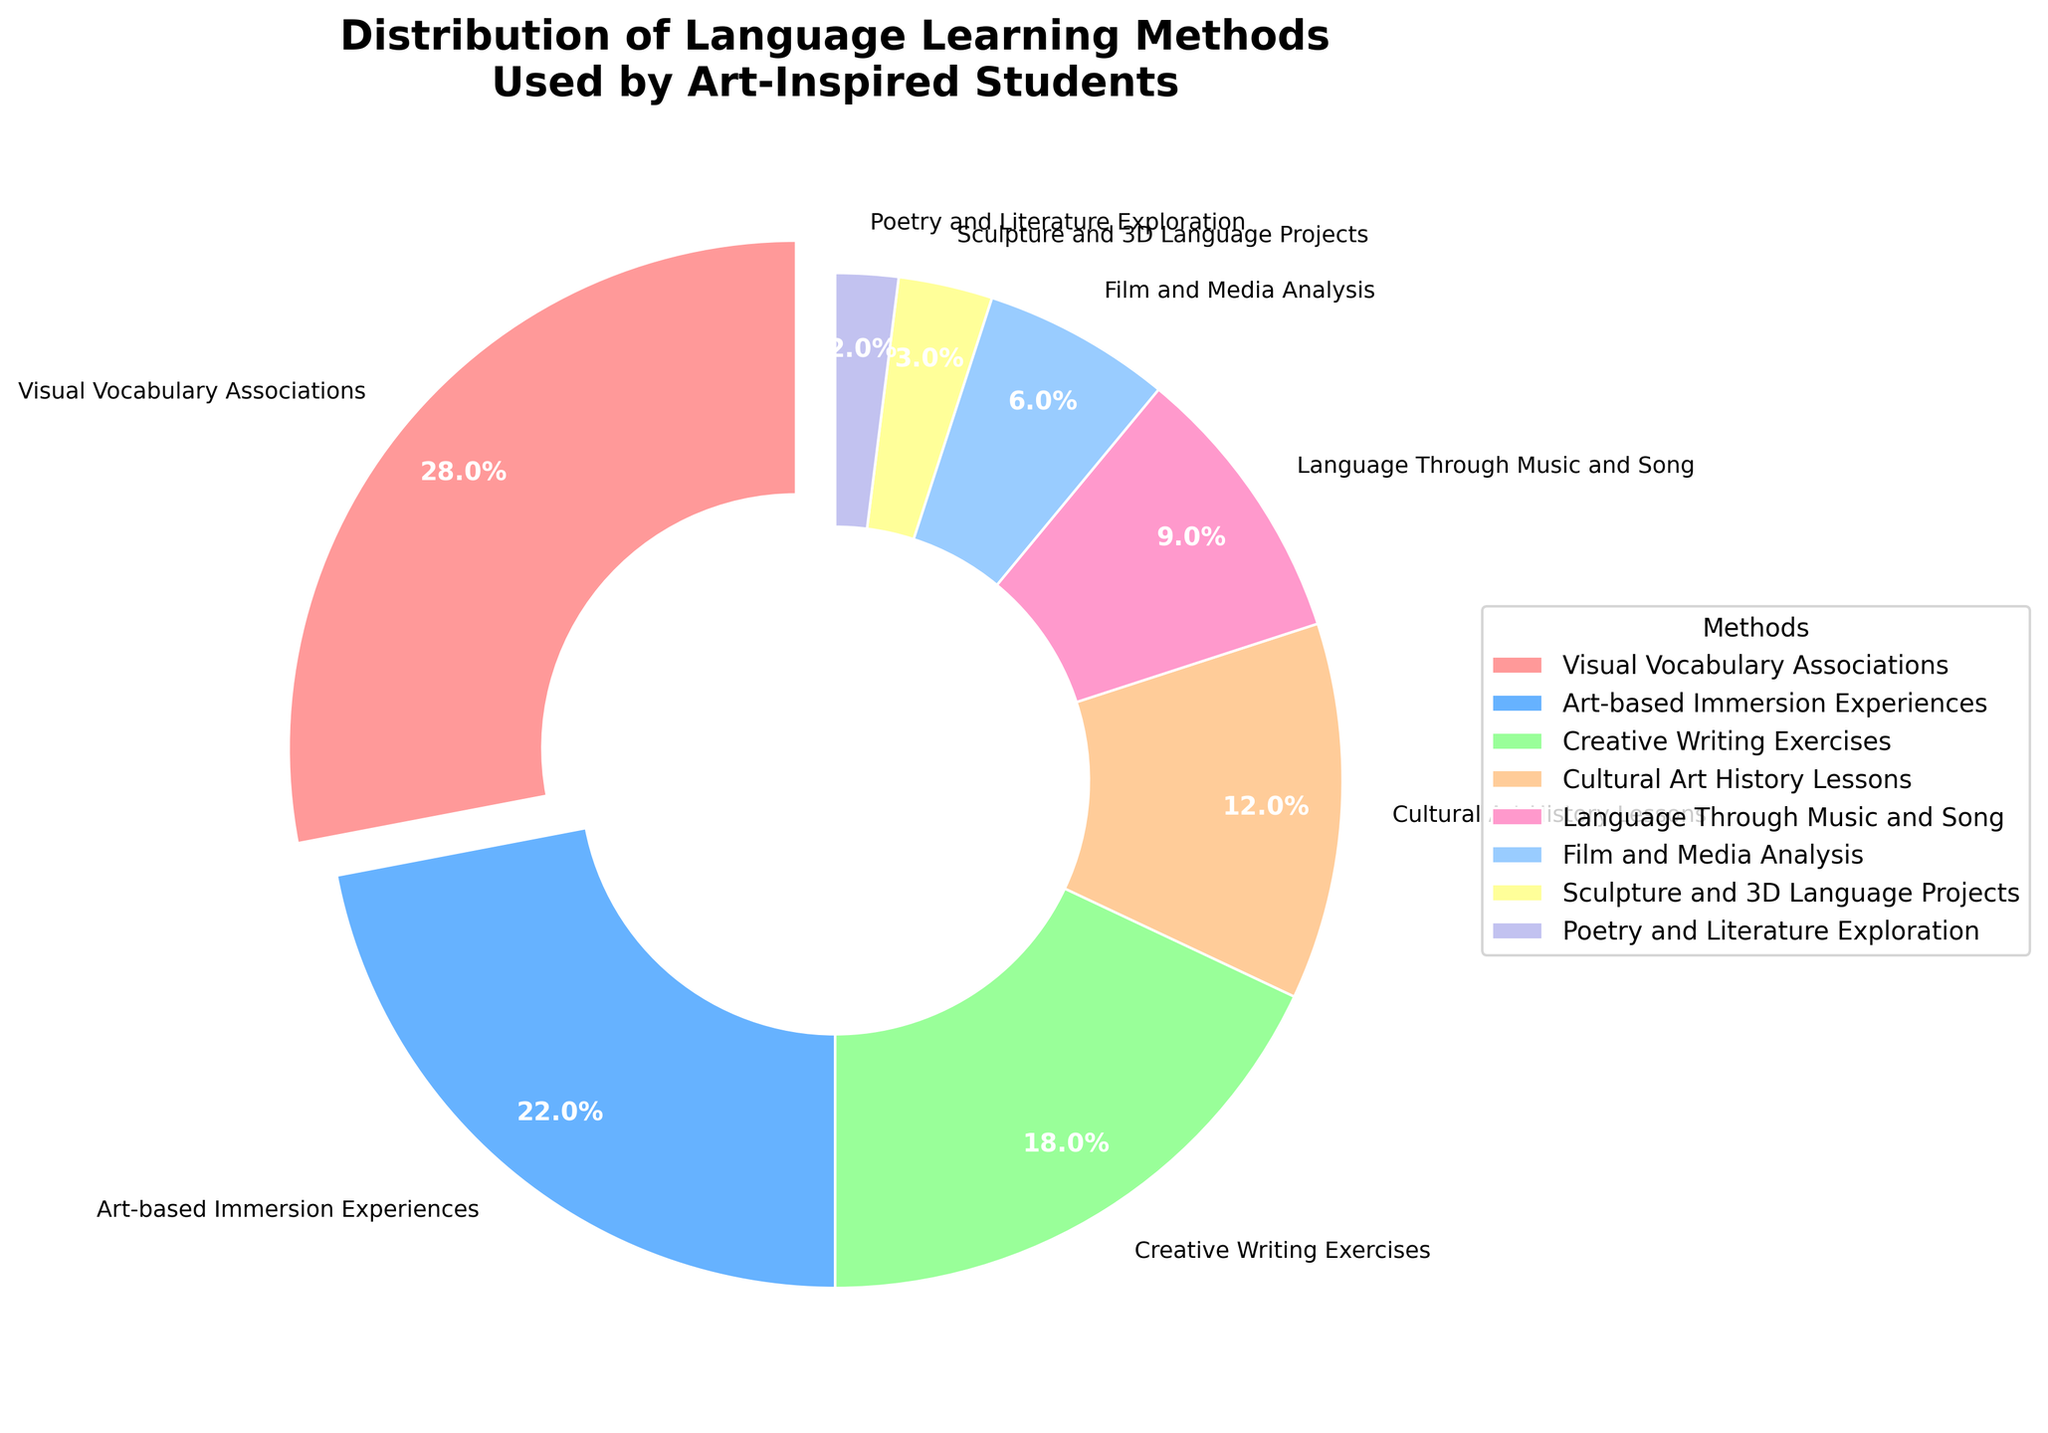Which language learning method is the most popular among art-inspired students? The largest segment of the pie chart corresponds to 'Visual Vocabulary Associations,' which indicates it is the most popular method.
Answer: Visual Vocabulary Associations What percentage of students use Creative Writing Exercises? Locate the segment labeled 'Creative Writing Exercises' on the pie chart and refer to the associated percentage value.
Answer: 18% How much more popular is Art-based Immersion Experiences compared to Sculpture and 3D Language Projects? Subtract the percentage of Sculpture and 3D Language Projects (3%) from the percentage of Art-based Immersion Experiences (22%).
Answer: 19% Which method occupies the smallest portion of the pie chart? The smallest segment of the pie chart represents 'Poetry and Literature Exploration.'
Answer: Poetry and Literature Exploration Compare the popularity of Language Through Music and Song and Film and Media Analysis. Which one is more preferred? Identify the percentages of both segments: Language Through Music and Song (9%) and Film and Media Analysis (6%). Compare these values to determine which is larger.
Answer: Language Through Music and Song What is the combined percentage of students using methods related to listening (Language Through Music and Song and Film and Media Analysis)? Add the percentages of 'Language Through Music and Song' (9%) and 'Film and Media Analysis' (6%).
Answer: 15% How much less popular is Poetry and Literature Exploration compared to Creative Writing Exercises? Subtract the percentage of Poetry and Literature Exploration (2%) from Creative Writing Exercises (18%).
Answer: 16% If we combine the percentages of Cultural Art History Lessons and Sculpture and 3D Language Projects, how much of the total do they represent? Add the percentages of 'Cultural Art History Lessons' (12%) and 'Sculpture and 3D Language Projects' (3%).
Answer: 15% Which color is associated with the Art-based Immersion Experiences segment in the pie chart? Identify the segment labeled 'Art-based Immersion Experiences' and note the corresponding color, which is visually represented on the chart.
Answer: Blue Is the percentage of students using Cultural Art History Lessons more than twice the percentage of those using Poetry and Literature Exploration? Double the percentage of Poetry and Literature Exploration (2% * 2 = 4%) and compare it to Cultural Art History Lessons (12%).
Answer: Yes 